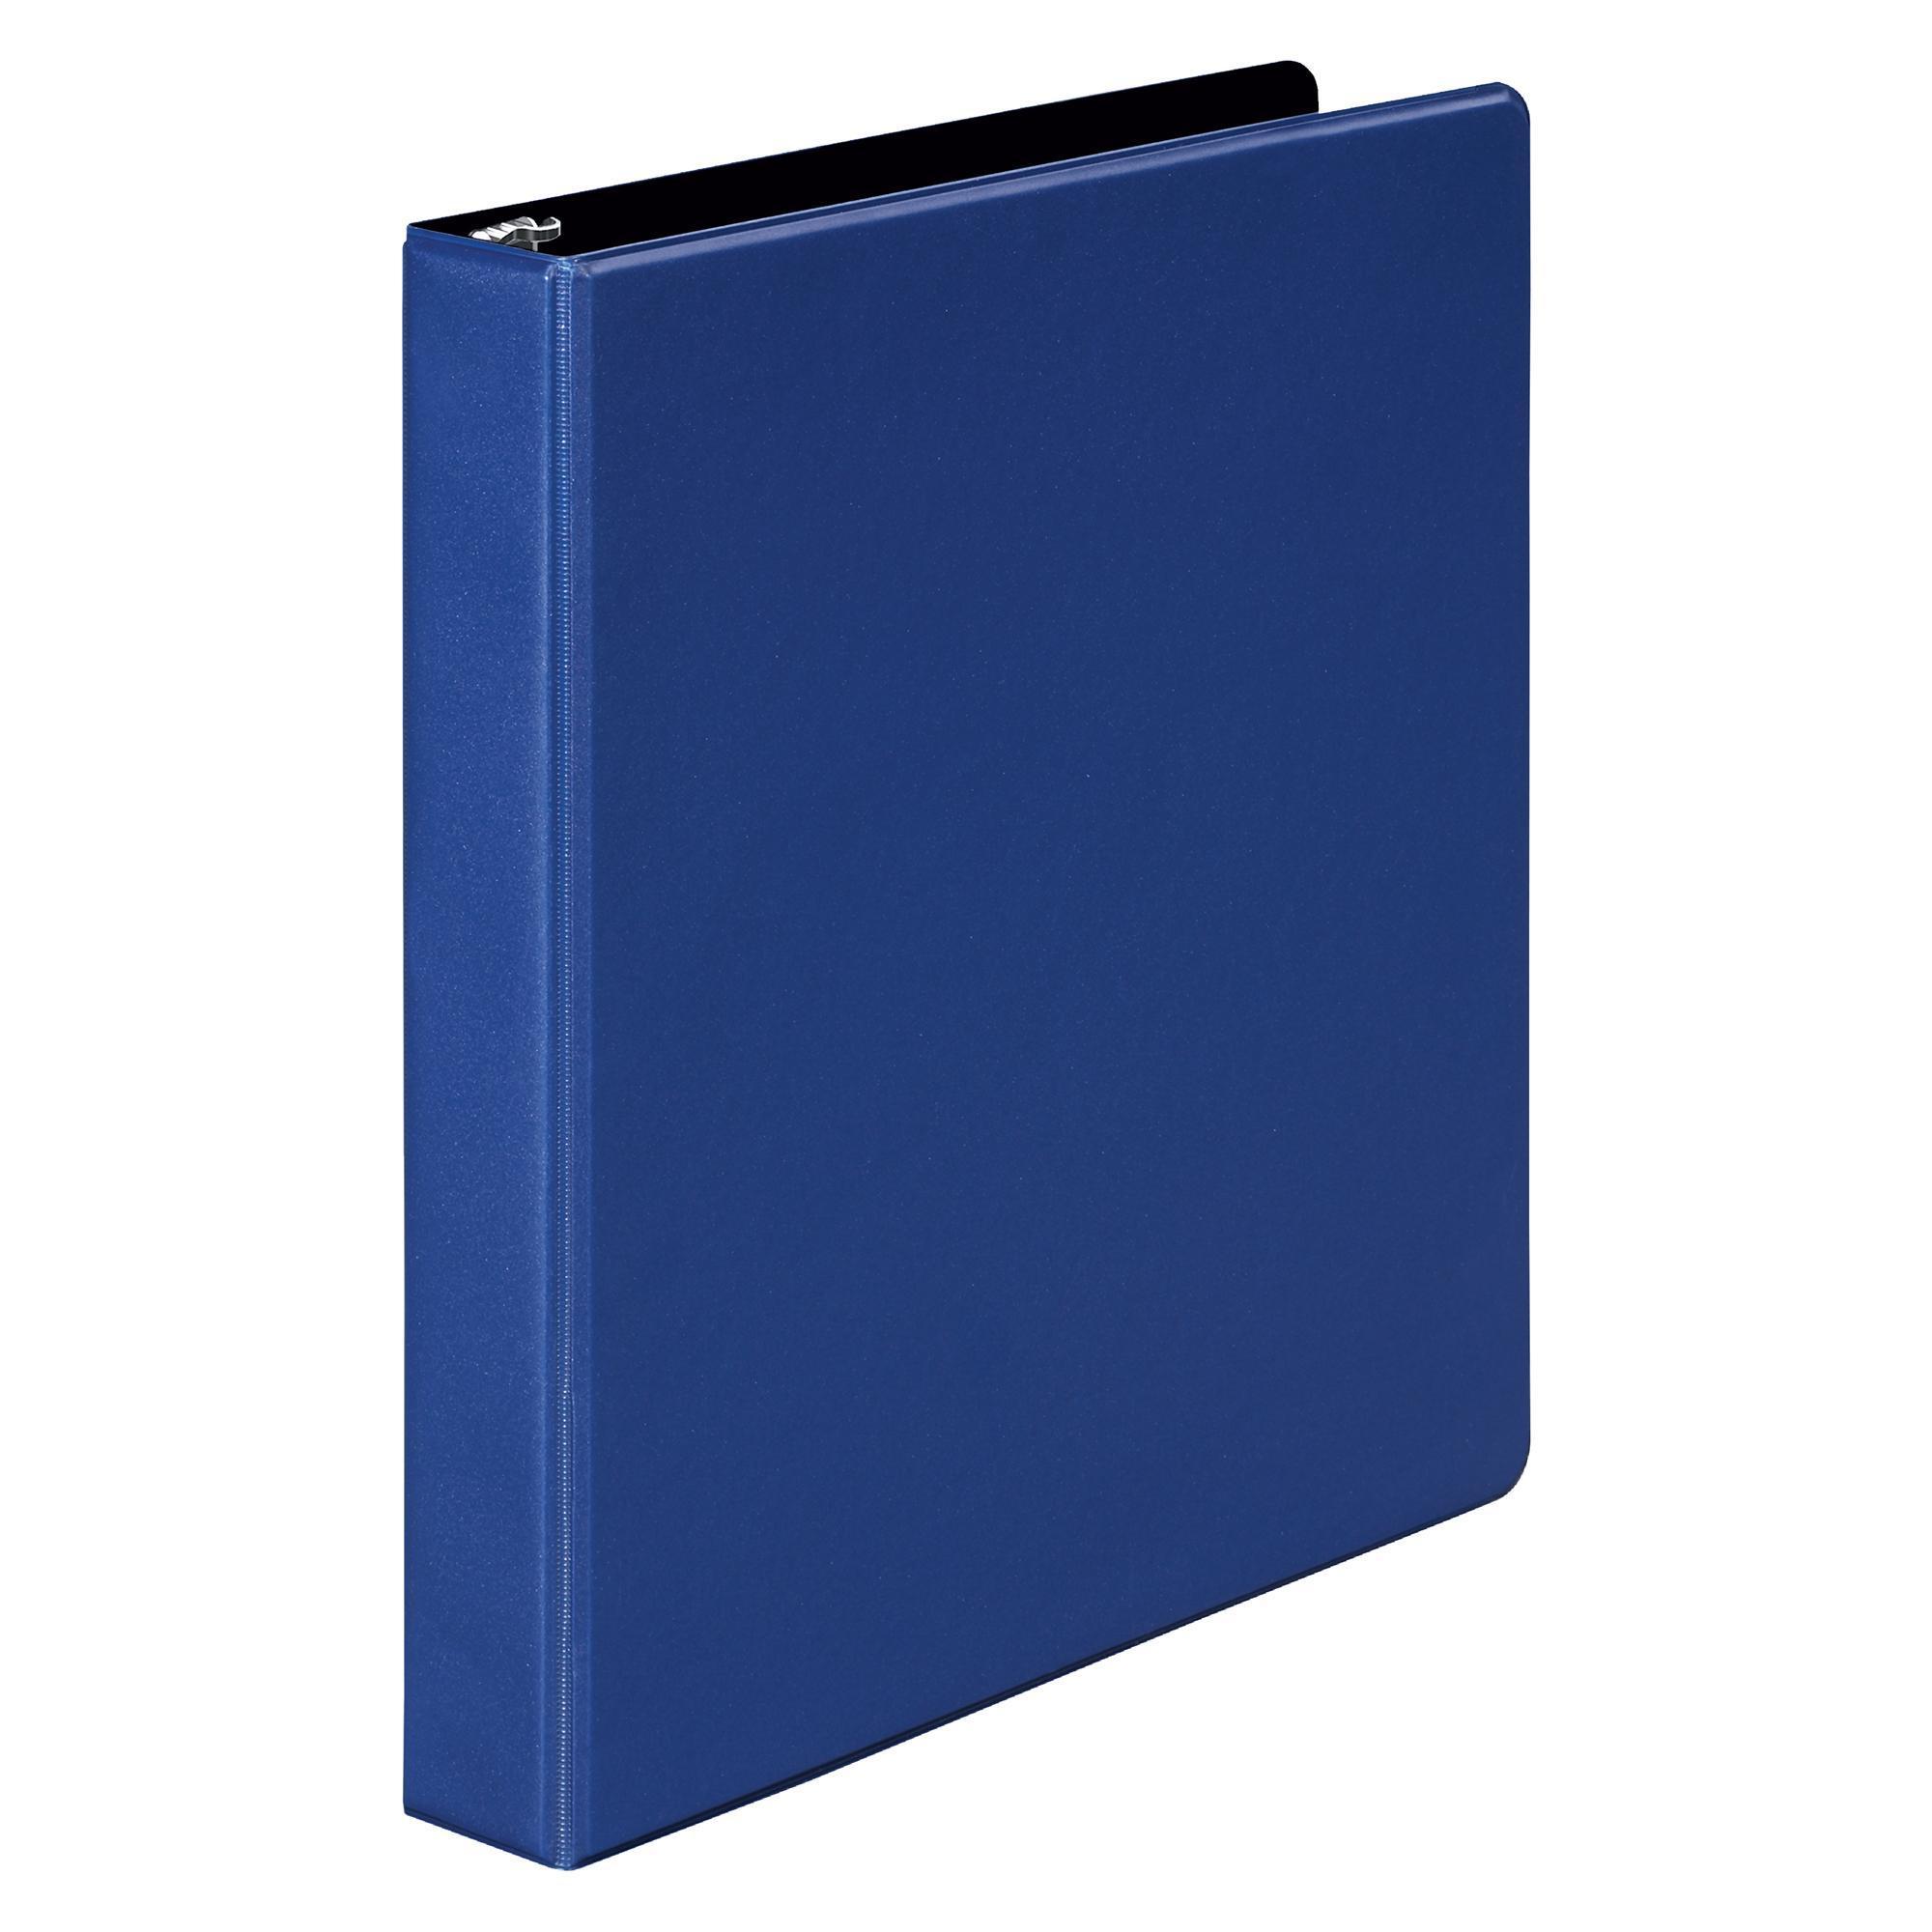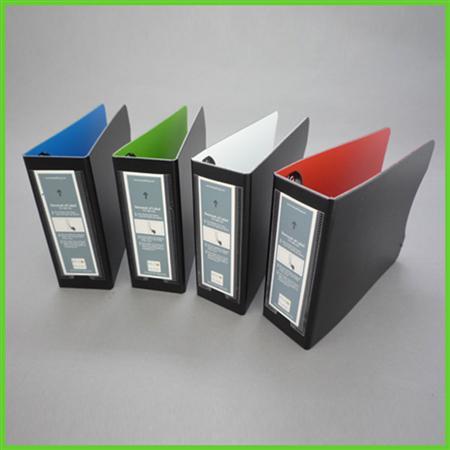The first image is the image on the left, the second image is the image on the right. For the images displayed, is the sentence "There are five binders in the image pair." factually correct? Answer yes or no. Yes. The first image is the image on the left, the second image is the image on the right. Examine the images to the left and right. Is the description "One image contains a single upright binder, and the other contains a row of four binders." accurate? Answer yes or no. Yes. 